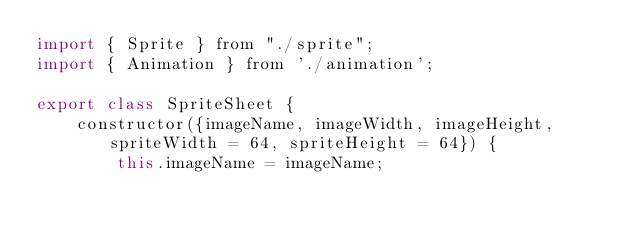Convert code to text. <code><loc_0><loc_0><loc_500><loc_500><_JavaScript_>import { Sprite } from "./sprite";
import { Animation } from './animation';

export class SpriteSheet {
    constructor({imageName, imageWidth, imageHeight, spriteWidth = 64, spriteHeight = 64}) {
        this.imageName = imageName;</code> 